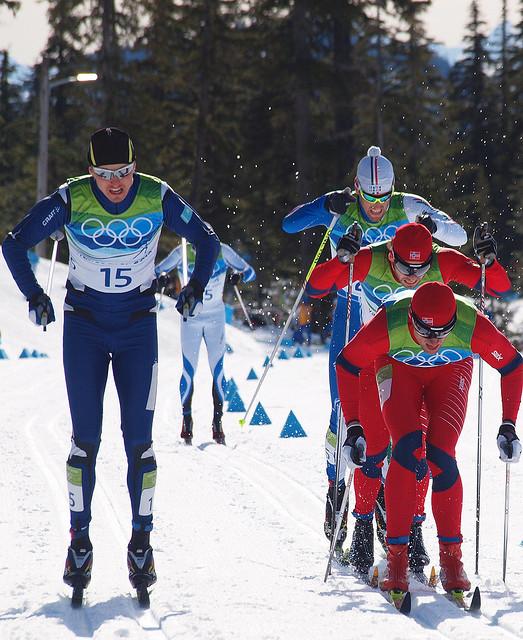What symbol is on the skiers' chest?
Quick response, please. Olympics. Why are some of them wearing different outfits?
Quick response, please. Different teams. Are they participating in the Olympic Games?
Be succinct. Yes. 